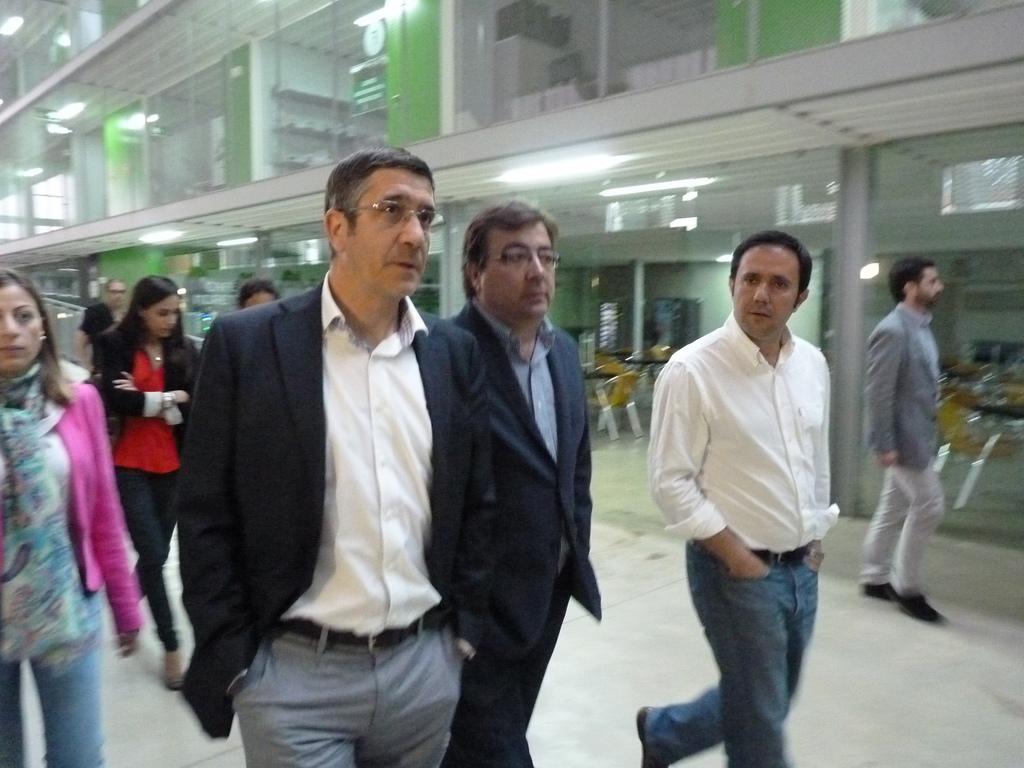How would you summarize this image in a sentence or two? Here men and women are walking, this is a building. 